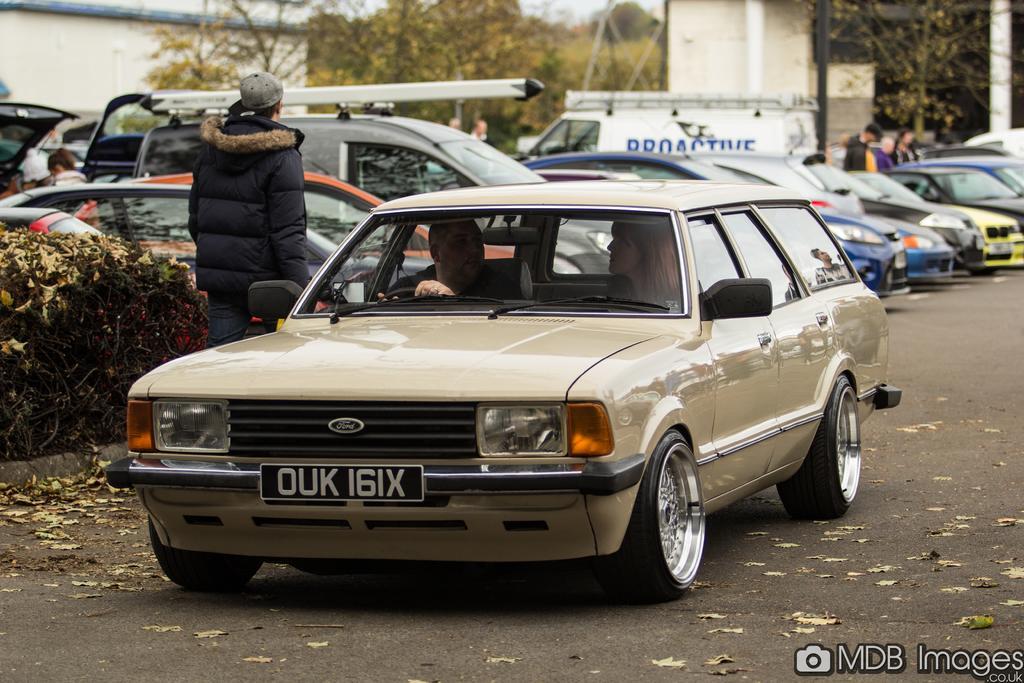Could you give a brief overview of what you see in this image? This person is standing and wore a jacket. These are vehicles. Inside this vehicle 2 persons are sitting. These are plants. Far there are trees and building. 